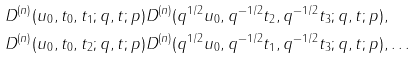<formula> <loc_0><loc_0><loc_500><loc_500>& D ^ { ( n ) } ( u _ { 0 } , t _ { 0 } , t _ { 1 } ; q , t ; p ) D ^ { ( n ) } ( q ^ { 1 / 2 } u _ { 0 } , q ^ { - 1 / 2 } t _ { 2 } , q ^ { - 1 / 2 } t _ { 3 } ; q , t ; p ) , \\ & D ^ { ( n ) } ( u _ { 0 } , t _ { 0 } , t _ { 2 } ; q , t ; p ) D ^ { ( n ) } ( q ^ { 1 / 2 } u _ { 0 } , q ^ { - 1 / 2 } t _ { 1 } , q ^ { - 1 / 2 } t _ { 3 } ; q , t ; p ) , \dots</formula> 